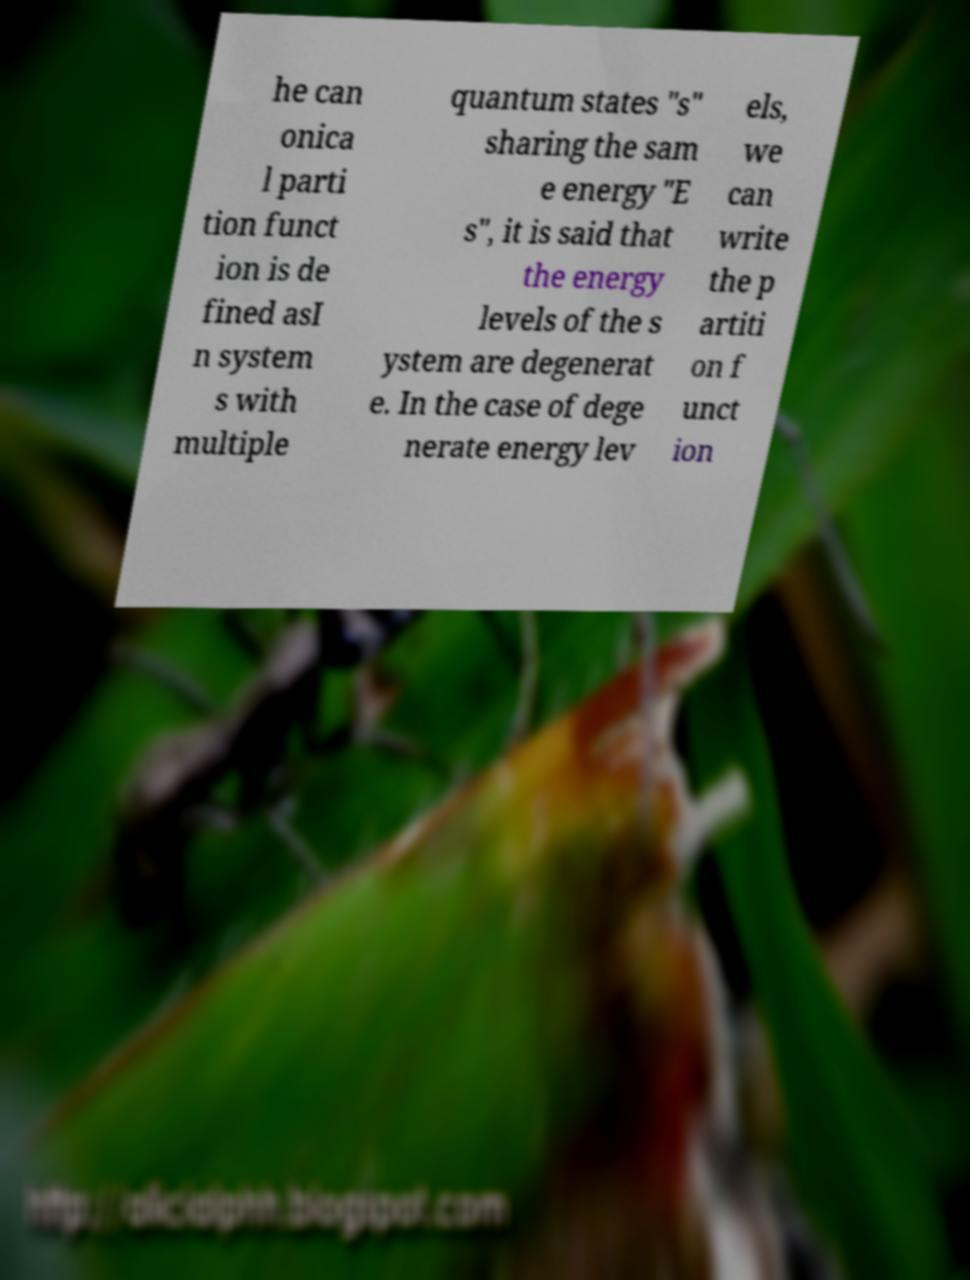Can you read and provide the text displayed in the image?This photo seems to have some interesting text. Can you extract and type it out for me? he can onica l parti tion funct ion is de fined asI n system s with multiple quantum states "s" sharing the sam e energy "E s", it is said that the energy levels of the s ystem are degenerat e. In the case of dege nerate energy lev els, we can write the p artiti on f unct ion 